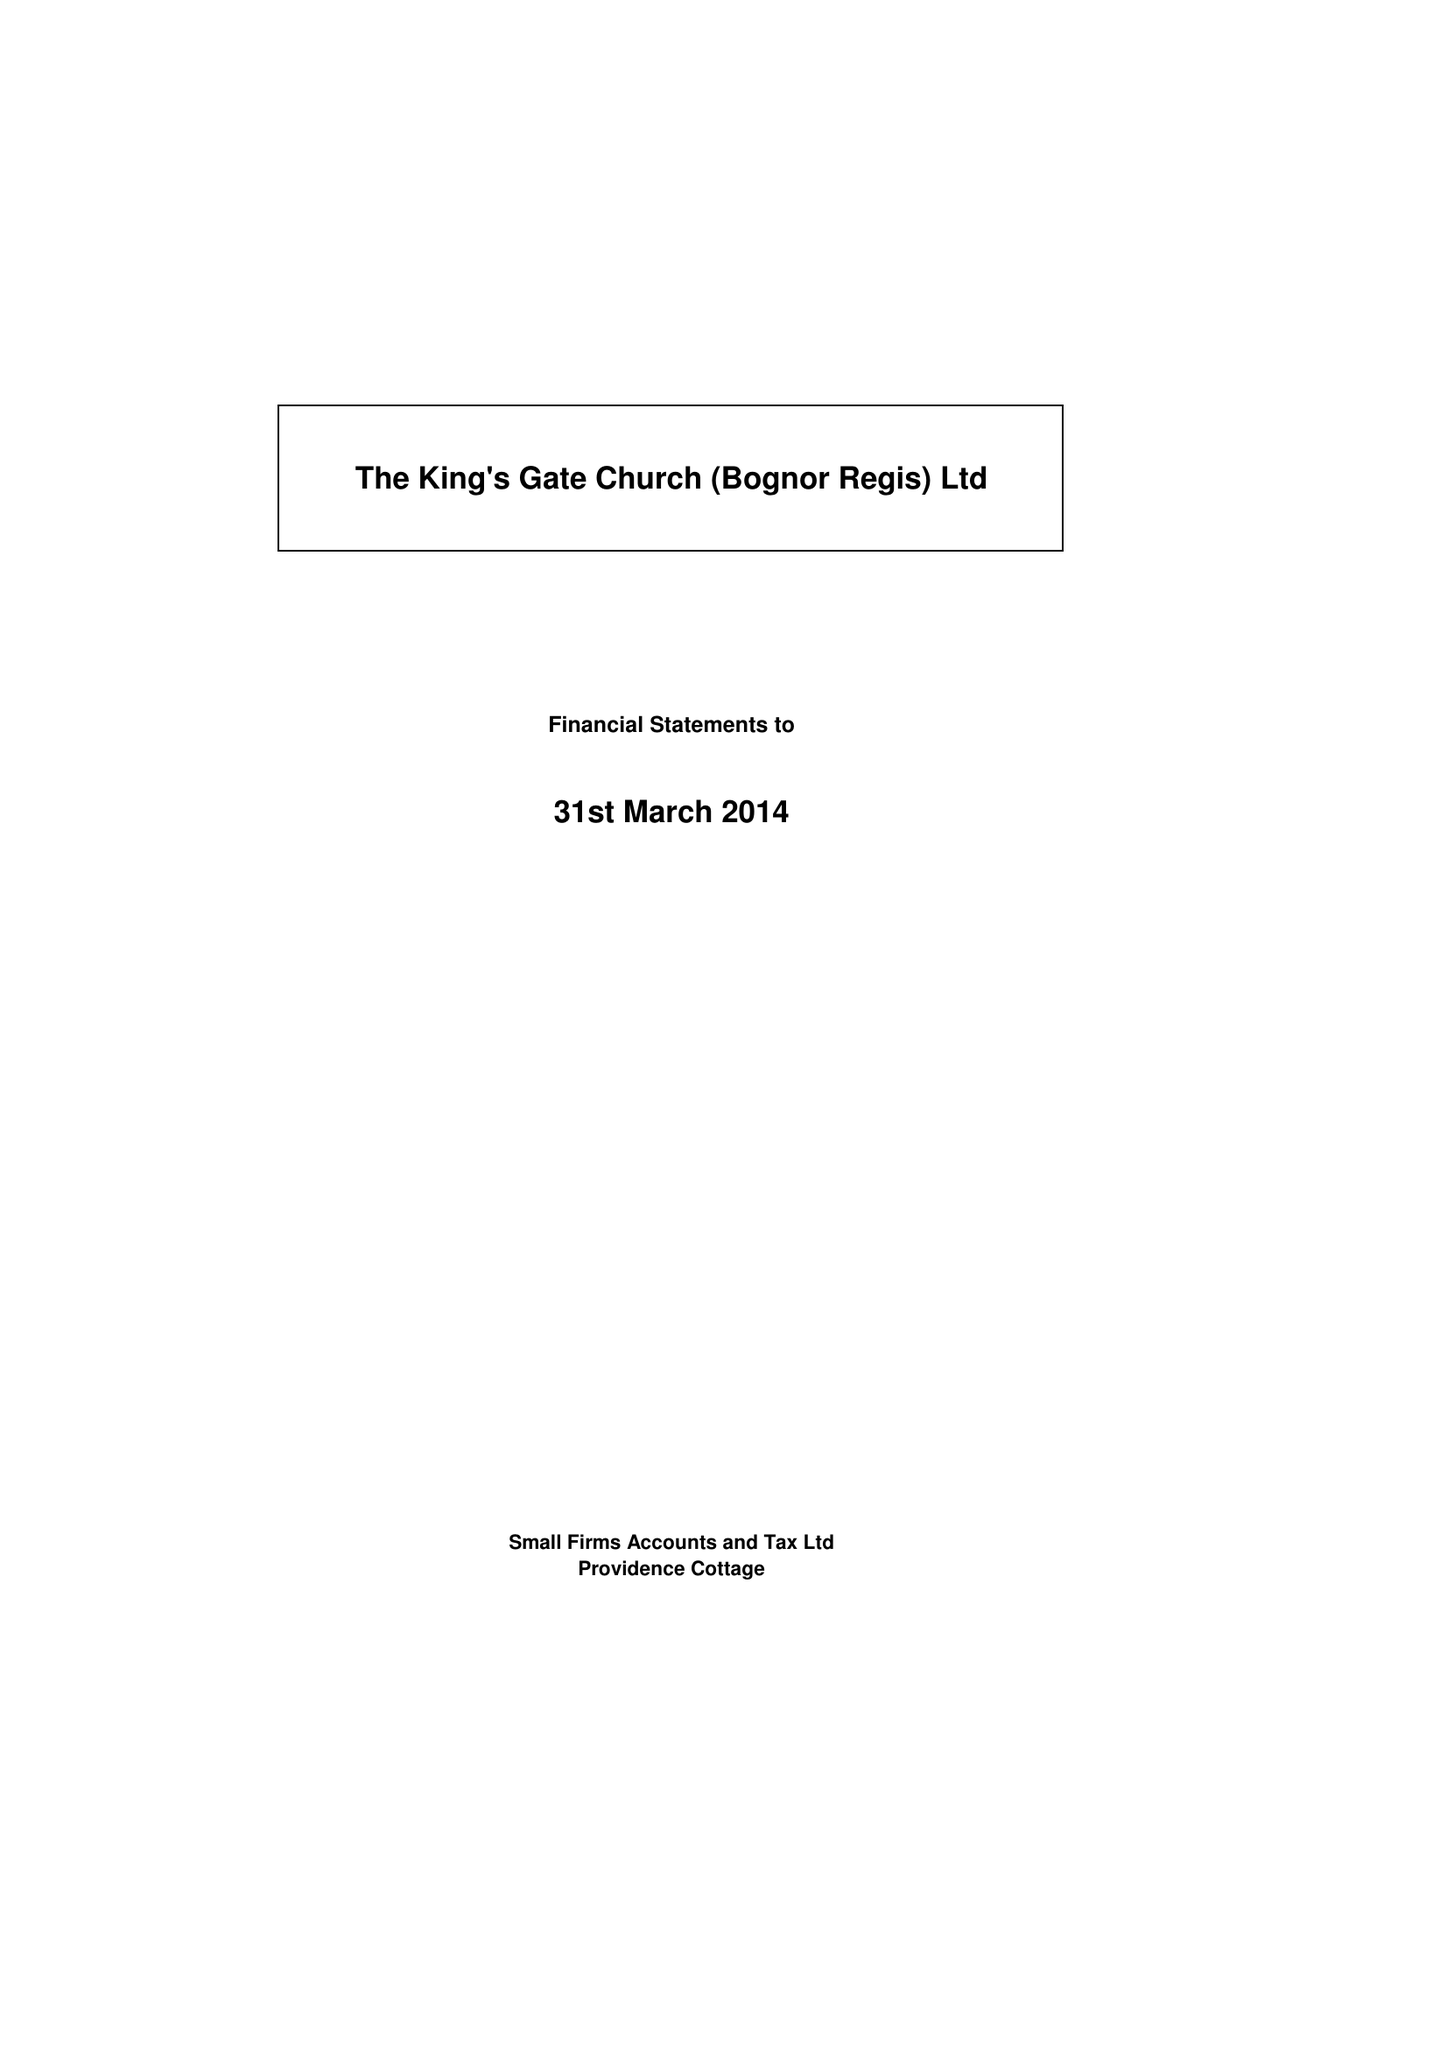What is the value for the address__street_line?
Answer the question using a single word or phrase. 30 CRESCENT ROAD 